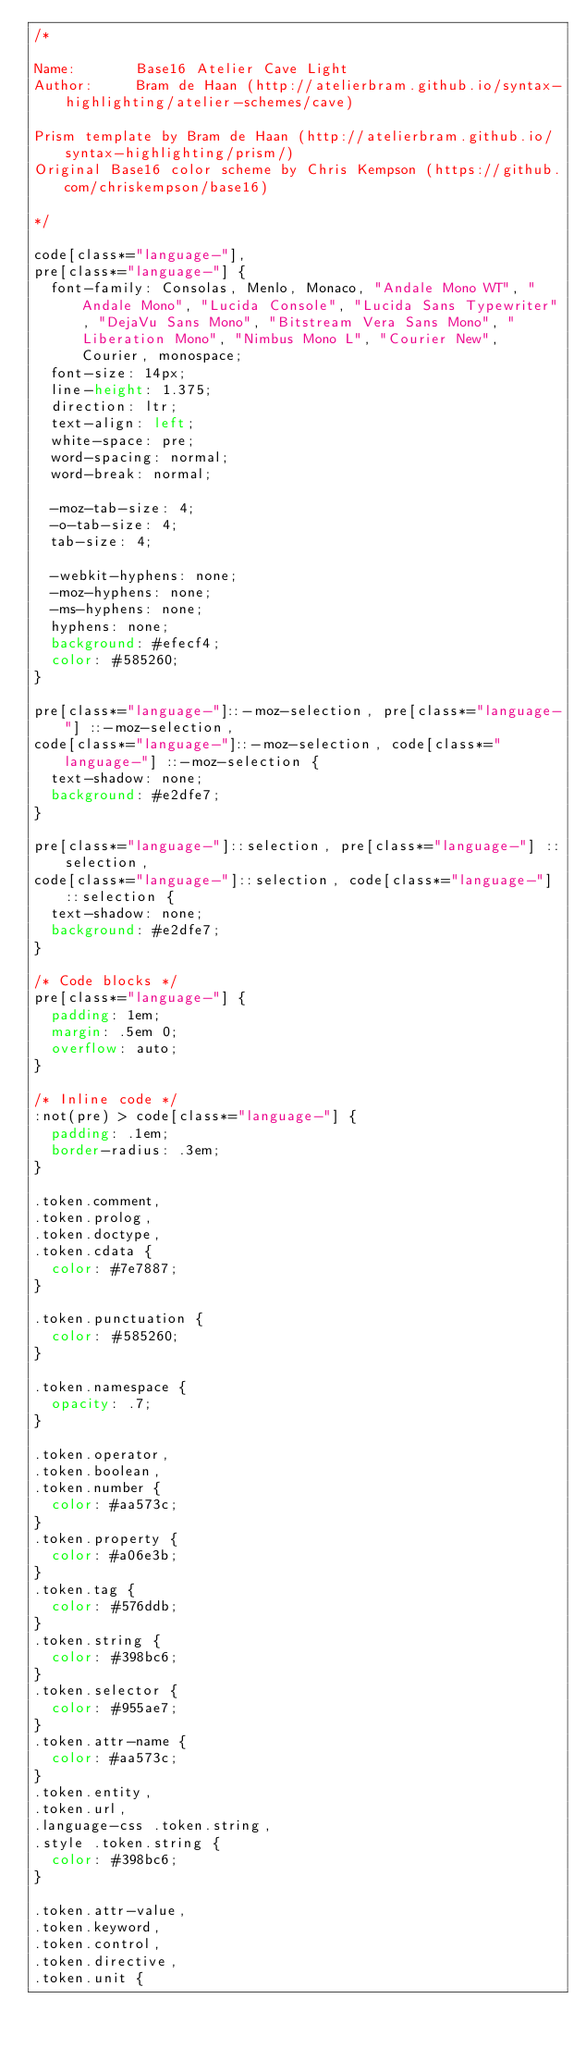Convert code to text. <code><loc_0><loc_0><loc_500><loc_500><_CSS_>/*

Name:       Base16 Atelier Cave Light
Author:     Bram de Haan (http://atelierbram.github.io/syntax-highlighting/atelier-schemes/cave)

Prism template by Bram de Haan (http://atelierbram.github.io/syntax-highlighting/prism/)
Original Base16 color scheme by Chris Kempson (https://github.com/chriskempson/base16)

*/

code[class*="language-"],
pre[class*="language-"] {
  font-family: Consolas, Menlo, Monaco, "Andale Mono WT", "Andale Mono", "Lucida Console", "Lucida Sans Typewriter", "DejaVu Sans Mono", "Bitstream Vera Sans Mono", "Liberation Mono", "Nimbus Mono L", "Courier New", Courier, monospace;
  font-size: 14px;
  line-height: 1.375;
  direction: ltr;
  text-align: left;
  white-space: pre;
  word-spacing: normal;
  word-break: normal;

  -moz-tab-size: 4;
  -o-tab-size: 4;
  tab-size: 4;

  -webkit-hyphens: none;
  -moz-hyphens: none;
  -ms-hyphens: none;
  hyphens: none;
  background: #efecf4;
  color: #585260;
}

pre[class*="language-"]::-moz-selection, pre[class*="language-"] ::-moz-selection,
code[class*="language-"]::-moz-selection, code[class*="language-"] ::-moz-selection {
  text-shadow: none;
  background: #e2dfe7;
}

pre[class*="language-"]::selection, pre[class*="language-"] ::selection,
code[class*="language-"]::selection, code[class*="language-"] ::selection {
  text-shadow: none;
  background: #e2dfe7;
}

/* Code blocks */
pre[class*="language-"] {
  padding: 1em;
  margin: .5em 0;
  overflow: auto;
}

/* Inline code */
:not(pre) > code[class*="language-"] {
  padding: .1em;
  border-radius: .3em;
}

.token.comment,
.token.prolog,
.token.doctype,
.token.cdata {
  color: #7e7887;
}

.token.punctuation {
  color: #585260;
}

.token.namespace {
  opacity: .7;
}

.token.operator,
.token.boolean,
.token.number {
  color: #aa573c;
}
.token.property {
  color: #a06e3b;
}
.token.tag {
  color: #576ddb;
}
.token.string {
  color: #398bc6;
}
.token.selector {
  color: #955ae7;
}
.token.attr-name {
  color: #aa573c;
}
.token.entity,
.token.url,
.language-css .token.string,
.style .token.string {
  color: #398bc6;
}

.token.attr-value,
.token.keyword,
.token.control,
.token.directive,
.token.unit {</code> 